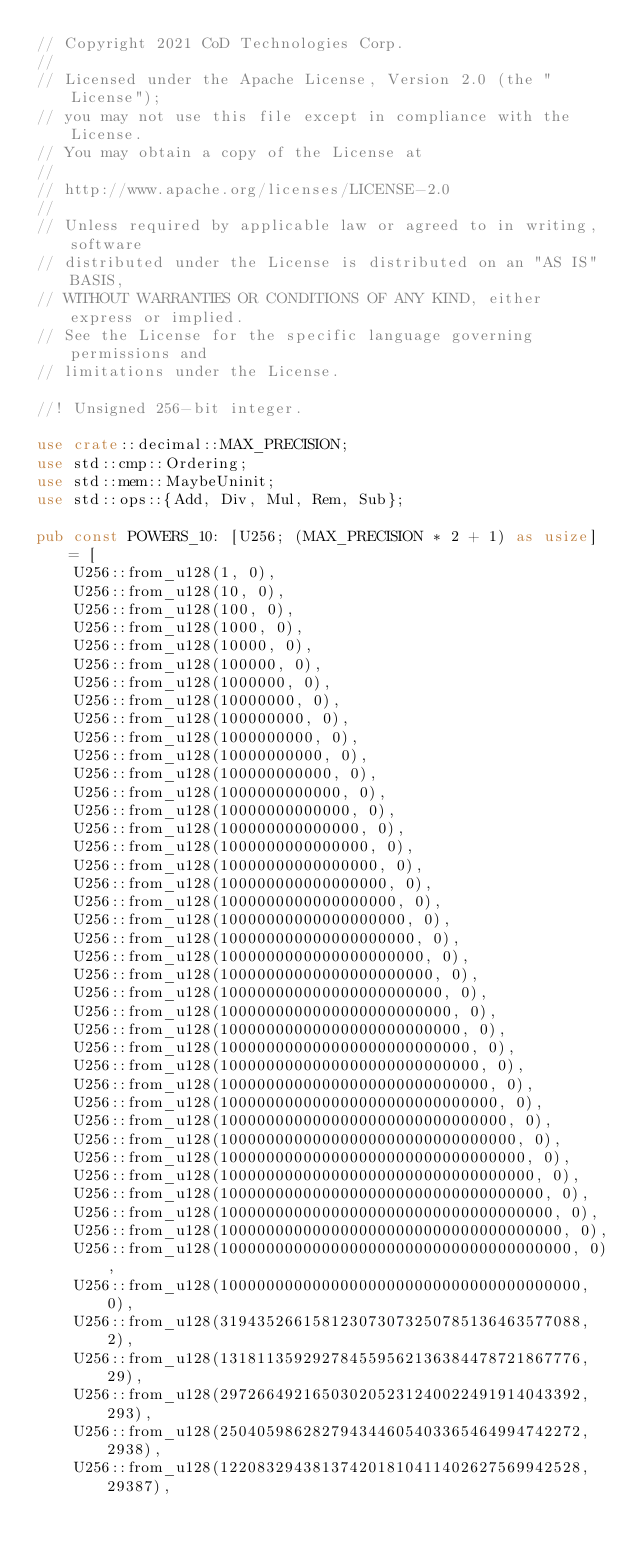Convert code to text. <code><loc_0><loc_0><loc_500><loc_500><_Rust_>// Copyright 2021 CoD Technologies Corp.
//
// Licensed under the Apache License, Version 2.0 (the "License");
// you may not use this file except in compliance with the License.
// You may obtain a copy of the License at
//
// http://www.apache.org/licenses/LICENSE-2.0
//
// Unless required by applicable law or agreed to in writing, software
// distributed under the License is distributed on an "AS IS" BASIS,
// WITHOUT WARRANTIES OR CONDITIONS OF ANY KIND, either express or implied.
// See the License for the specific language governing permissions and
// limitations under the License.

//! Unsigned 256-bit integer.

use crate::decimal::MAX_PRECISION;
use std::cmp::Ordering;
use std::mem::MaybeUninit;
use std::ops::{Add, Div, Mul, Rem, Sub};

pub const POWERS_10: [U256; (MAX_PRECISION * 2 + 1) as usize] = [
    U256::from_u128(1, 0),
    U256::from_u128(10, 0),
    U256::from_u128(100, 0),
    U256::from_u128(1000, 0),
    U256::from_u128(10000, 0),
    U256::from_u128(100000, 0),
    U256::from_u128(1000000, 0),
    U256::from_u128(10000000, 0),
    U256::from_u128(100000000, 0),
    U256::from_u128(1000000000, 0),
    U256::from_u128(10000000000, 0),
    U256::from_u128(100000000000, 0),
    U256::from_u128(1000000000000, 0),
    U256::from_u128(10000000000000, 0),
    U256::from_u128(100000000000000, 0),
    U256::from_u128(1000000000000000, 0),
    U256::from_u128(10000000000000000, 0),
    U256::from_u128(100000000000000000, 0),
    U256::from_u128(1000000000000000000, 0),
    U256::from_u128(10000000000000000000, 0),
    U256::from_u128(100000000000000000000, 0),
    U256::from_u128(1000000000000000000000, 0),
    U256::from_u128(10000000000000000000000, 0),
    U256::from_u128(100000000000000000000000, 0),
    U256::from_u128(1000000000000000000000000, 0),
    U256::from_u128(10000000000000000000000000, 0),
    U256::from_u128(100000000000000000000000000, 0),
    U256::from_u128(1000000000000000000000000000, 0),
    U256::from_u128(10000000000000000000000000000, 0),
    U256::from_u128(100000000000000000000000000000, 0),
    U256::from_u128(1000000000000000000000000000000, 0),
    U256::from_u128(10000000000000000000000000000000, 0),
    U256::from_u128(100000000000000000000000000000000, 0),
    U256::from_u128(1000000000000000000000000000000000, 0),
    U256::from_u128(10000000000000000000000000000000000, 0),
    U256::from_u128(100000000000000000000000000000000000, 0),
    U256::from_u128(1000000000000000000000000000000000000, 0),
    U256::from_u128(10000000000000000000000000000000000000, 0),
    U256::from_u128(100000000000000000000000000000000000000, 0),
    U256::from_u128(319435266158123073073250785136463577088, 2),
    U256::from_u128(131811359292784559562136384478721867776, 29),
    U256::from_u128(297266492165030205231240022491914043392, 293),
    U256::from_u128(250405986282794344605403365464994742272, 2938),
    U256::from_u128(122083294381374201810411402627569942528, 29387),</code> 